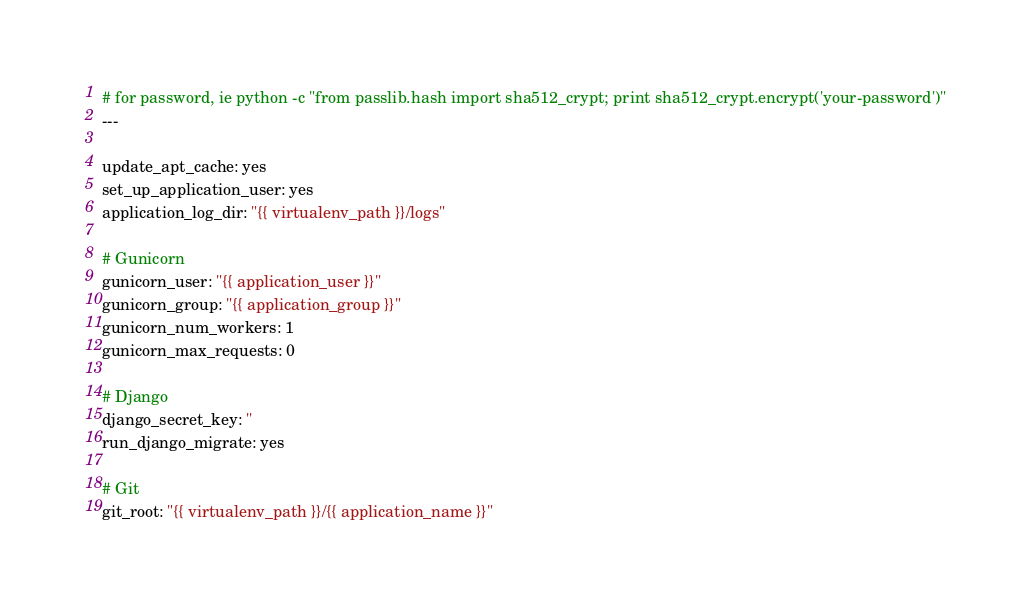<code> <loc_0><loc_0><loc_500><loc_500><_YAML_># for password, ie python -c "from passlib.hash import sha512_crypt; print sha512_crypt.encrypt('your-password')"
---

update_apt_cache: yes
set_up_application_user: yes
application_log_dir: "{{ virtualenv_path }}/logs"

# Gunicorn
gunicorn_user: "{{ application_user }}"
gunicorn_group: "{{ application_group }}"
gunicorn_num_workers: 1
gunicorn_max_requests: 0

# Django
django_secret_key: ''
run_django_migrate: yes

# Git
git_root: "{{ virtualenv_path }}/{{ application_name }}"</code> 